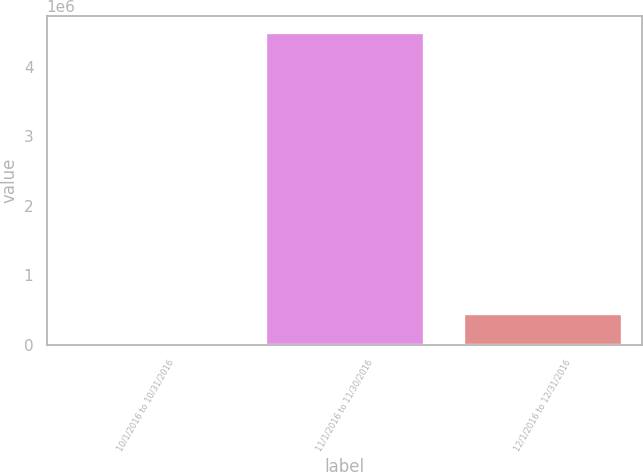Convert chart. <chart><loc_0><loc_0><loc_500><loc_500><bar_chart><fcel>10/1/2016 to 10/31/2016<fcel>11/1/2016 to 11/30/2016<fcel>12/1/2016 to 12/31/2016<nl><fcel>1.34<fcel>4.50067e+06<fcel>450068<nl></chart> 